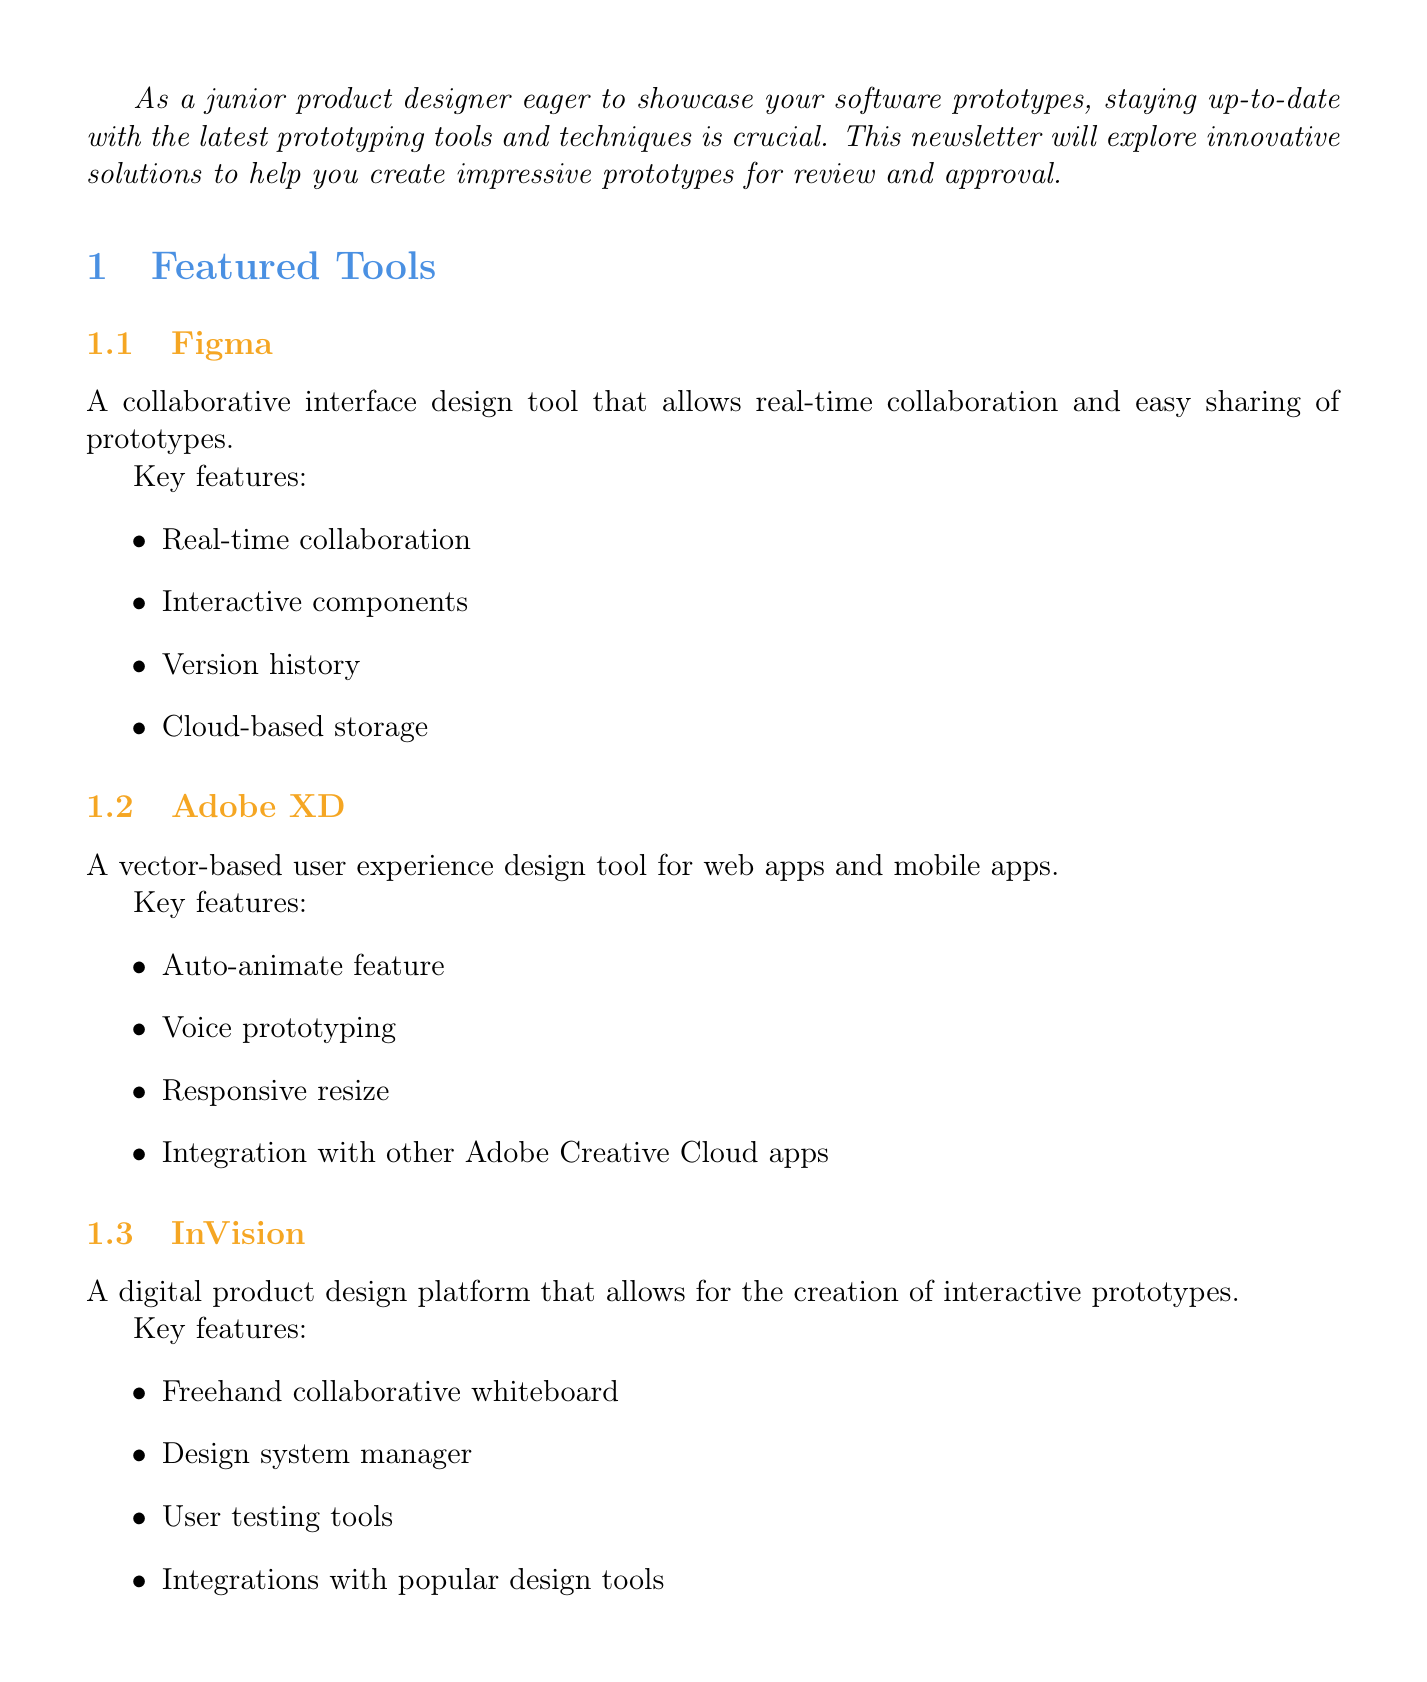What is the title of the newsletter? The title of the newsletter is presented at the top of the document as the main header.
Answer: Innovative Prototyping Tools and Techniques for Junior Product Designers How many featured tools are listed in the newsletter? The featured tools are summarized in a specific section of the document, where each tool is mentioned.
Answer: 3 What is the first step in the Figma tutorial? The tutorial section outlines a series of steps; the first step is described in detail.
Answer: Set up your Figma account and create a new design file Name one innovative technique mentioned in the document. The innovative techniques are listed; one can be chosen from those mentioned.
Answer: Micro-interactions What key feature is unique to Adobe XD compared to other tools? The key features for each tool are compared, identifying unique aspects for Adobe XD.
Answer: Voice prototyping What is a tip for junior designers regarding prototyping? Tips are provided in a specific section aimed at junior designers, highlighting important practices.
Answer: Always start with low-fidelity wireframes before moving to high-fidelity prototypes Which tool is described as having real-time collaboration? The description of the tools includes key features, helping identify which one supports this capability.
Answer: Figma What example is given for AR/VR prototyping? Examples are provided for each innovative technique, showcasing practical applications.
Answer: Design an AR furniture placement app prototype using Apple's Reality Composer 